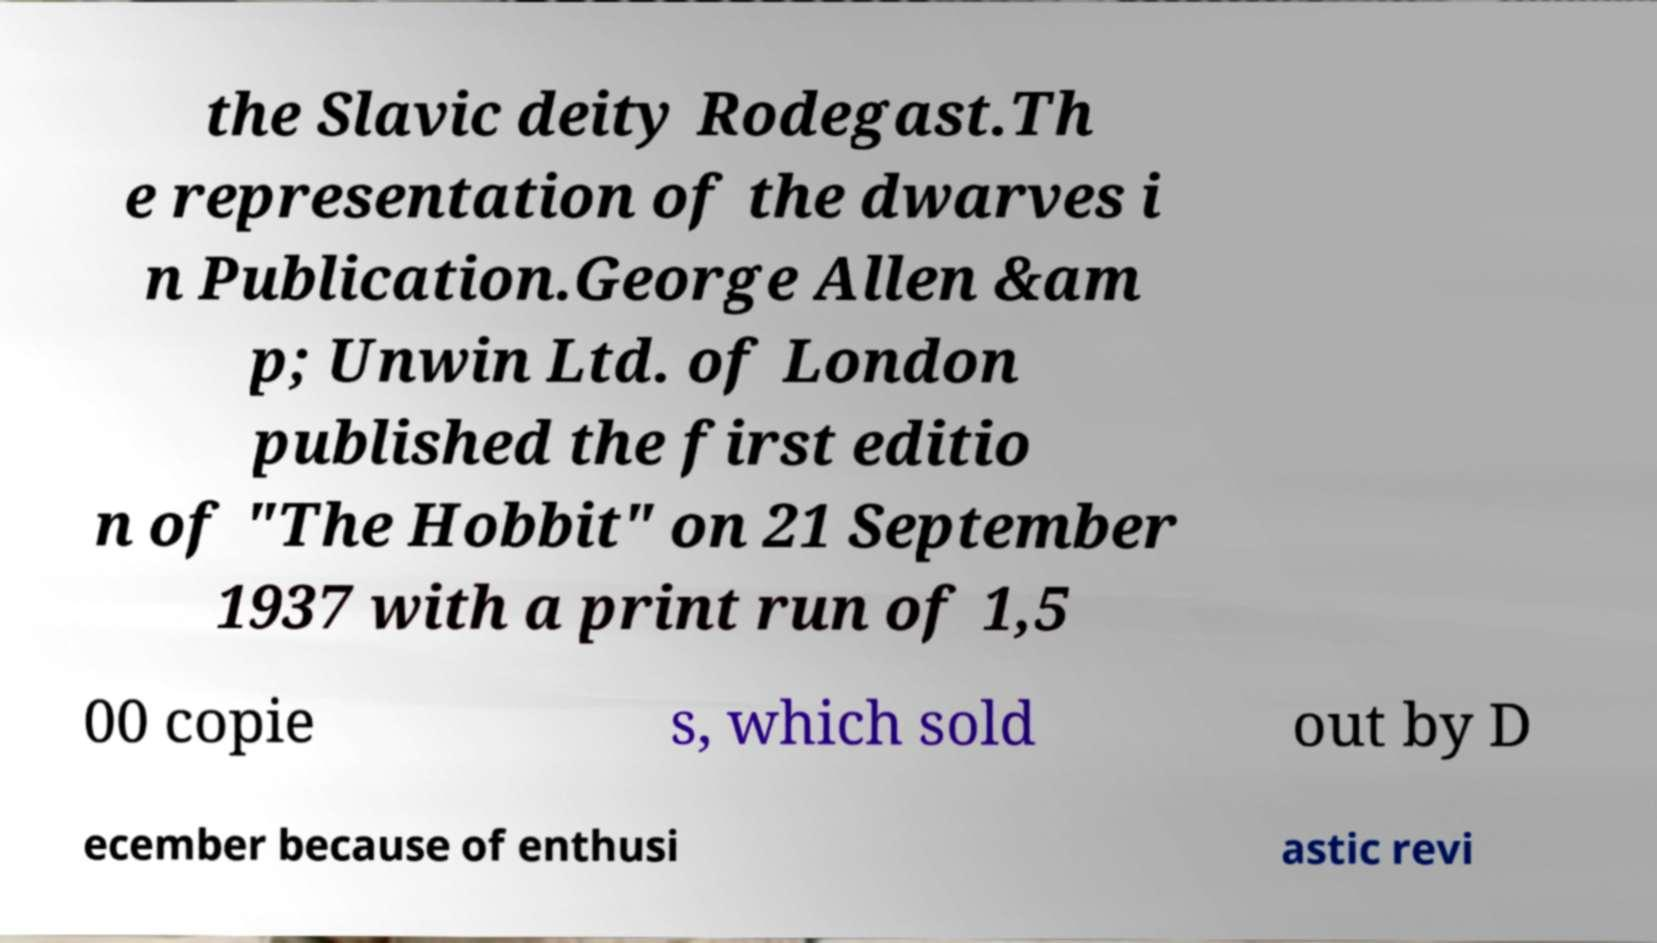There's text embedded in this image that I need extracted. Can you transcribe it verbatim? the Slavic deity Rodegast.Th e representation of the dwarves i n Publication.George Allen &am p; Unwin Ltd. of London published the first editio n of "The Hobbit" on 21 September 1937 with a print run of 1,5 00 copie s, which sold out by D ecember because of enthusi astic revi 